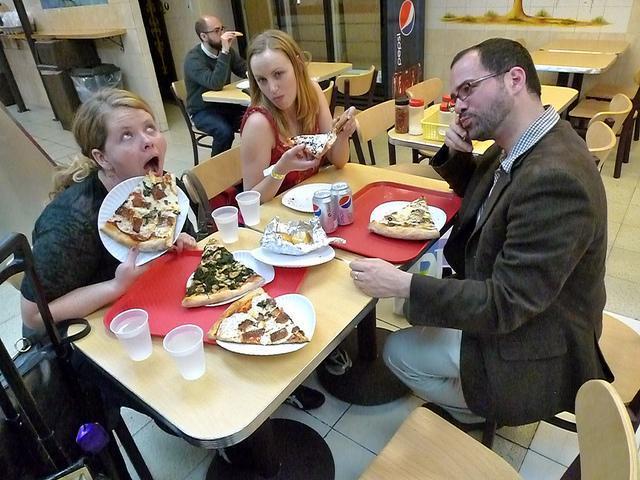How many people are in the picture?
Give a very brief answer. 4. How many pizzas are there?
Give a very brief answer. 4. How many chairs can you see?
Give a very brief answer. 5. How many dining tables are there?
Give a very brief answer. 2. How many people are there?
Give a very brief answer. 4. How many trains are moving?
Give a very brief answer. 0. 